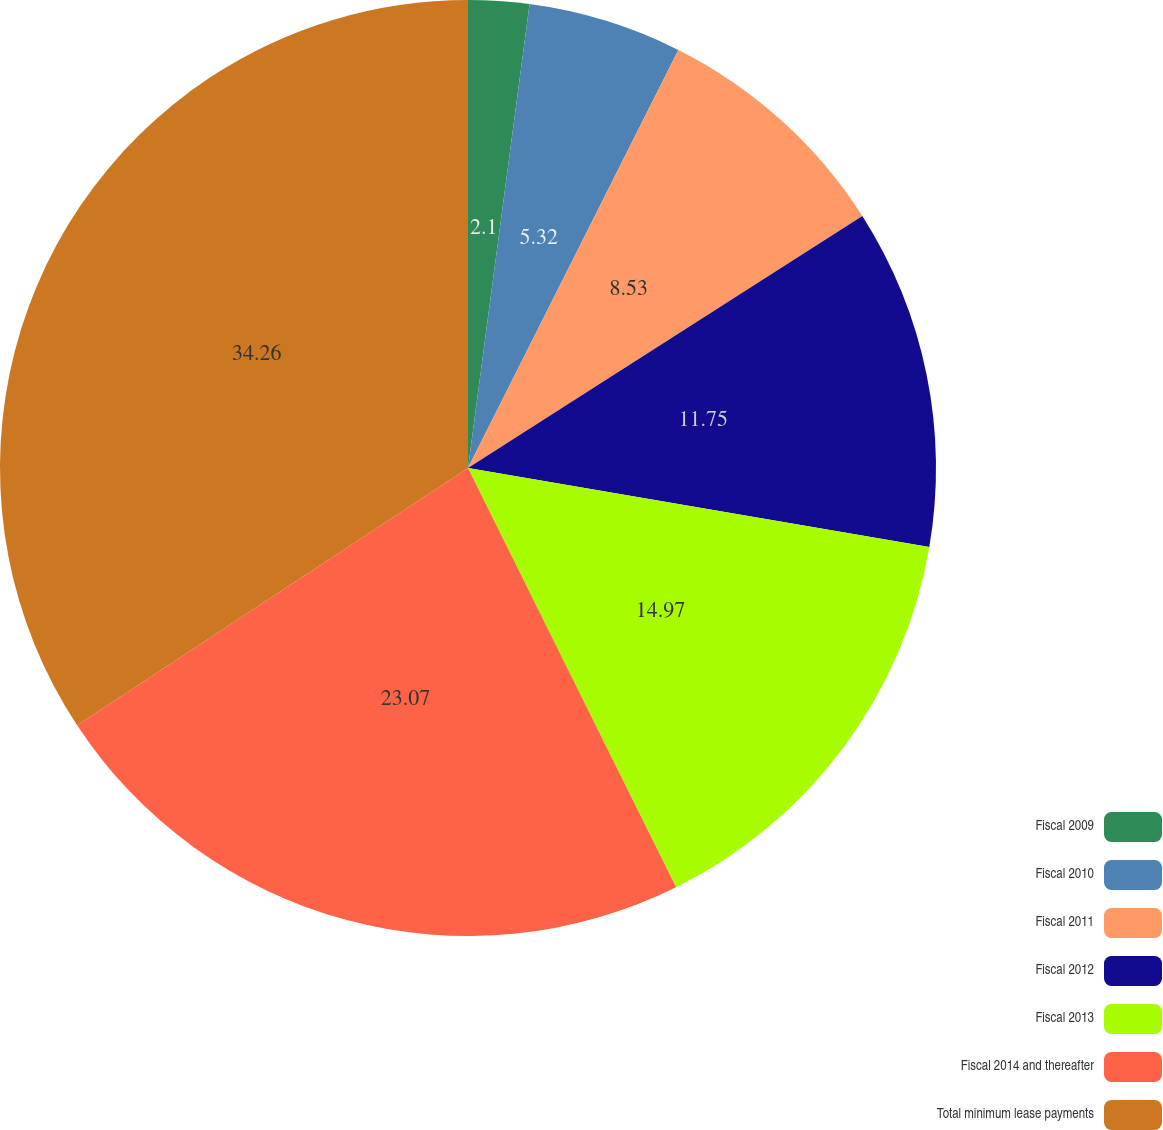Convert chart to OTSL. <chart><loc_0><loc_0><loc_500><loc_500><pie_chart><fcel>Fiscal 2009<fcel>Fiscal 2010<fcel>Fiscal 2011<fcel>Fiscal 2012<fcel>Fiscal 2013<fcel>Fiscal 2014 and thereafter<fcel>Total minimum lease payments<nl><fcel>2.1%<fcel>5.32%<fcel>8.53%<fcel>11.75%<fcel>14.97%<fcel>23.07%<fcel>34.27%<nl></chart> 